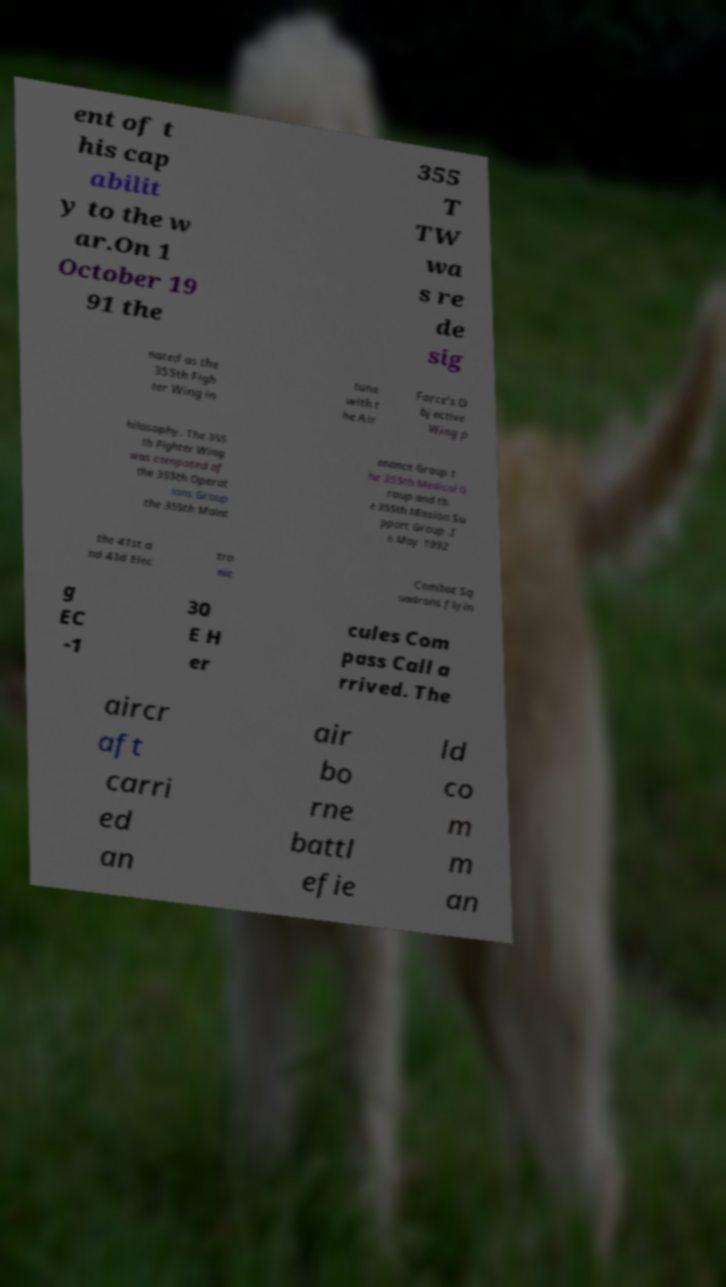I need the written content from this picture converted into text. Can you do that? ent of t his cap abilit y to the w ar.On 1 October 19 91 the 355 T TW wa s re de sig nated as the 355th Figh ter Wing in tune with t he Air Force's O bjective Wing p hilosophy. The 355 th Fighter Wing was composed of the 355th Operat ions Group the 355th Maint enance Group t he 355th Medical G roup and th e 355th Mission Su pport Group .I n May 1992 the 41st a nd 43d Elec tro nic Combat Sq uadrons flyin g EC -1 30 E H er cules Com pass Call a rrived. The aircr aft carri ed an air bo rne battl efie ld co m m an 